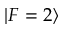<formula> <loc_0><loc_0><loc_500><loc_500>| F = 2 \rangle</formula> 